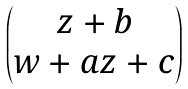<formula> <loc_0><loc_0><loc_500><loc_500>\begin{pmatrix} z + b \\ w + a z + c \end{pmatrix}</formula> 